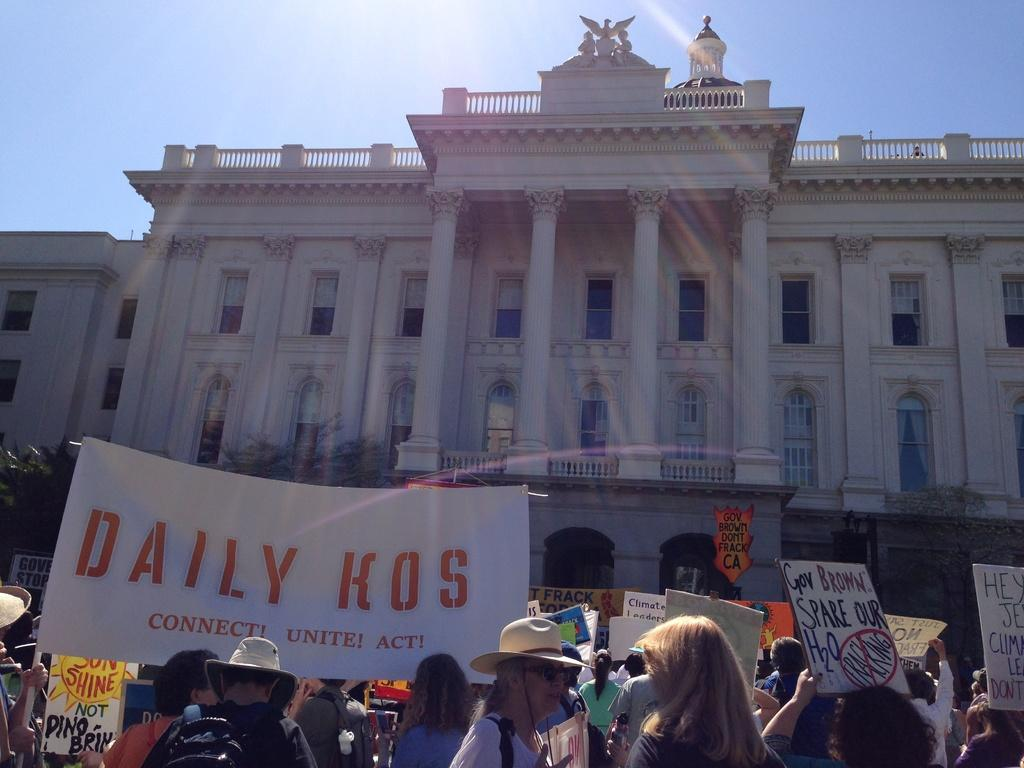How many people are in the group visible in the image? There is a group of people in the image, but the exact number cannot be determined from the provided facts. What objects can be seen in the image besides the people? There are boards visible in the image. What can be seen in the background of the image? In the background of the image, there is a building, pillars, windows, and the sky. What is the weight of the zebra in the image? There is no zebra present in the image, so its weight cannot be determined. What channel is the group of people watching in the image? There is no reference to a channel or any television in the image, so it's not possible to determine what they might be watching. 